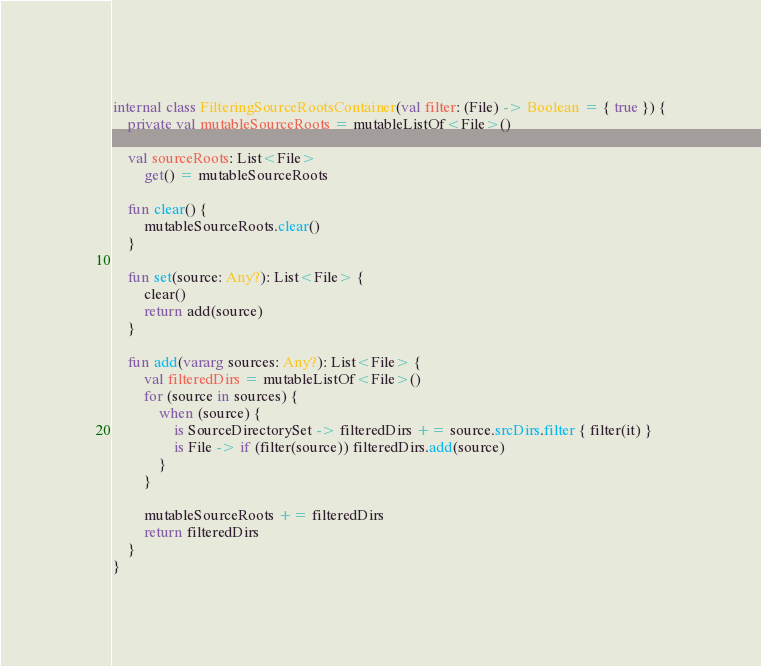<code> <loc_0><loc_0><loc_500><loc_500><_Kotlin_>
internal class FilteringSourceRootsContainer(val filter: (File) -> Boolean = { true }) {
    private val mutableSourceRoots = mutableListOf<File>()

    val sourceRoots: List<File>
        get() = mutableSourceRoots

    fun clear() {
        mutableSourceRoots.clear()
    }

    fun set(source: Any?): List<File> {
        clear()
        return add(source)
    }

    fun add(vararg sources: Any?): List<File> {
        val filteredDirs = mutableListOf<File>()
        for (source in sources) {
            when (source) {
                is SourceDirectorySet -> filteredDirs += source.srcDirs.filter { filter(it) }
                is File -> if (filter(source)) filteredDirs.add(source)
            }
        }

        mutableSourceRoots += filteredDirs
        return filteredDirs
    }
}</code> 